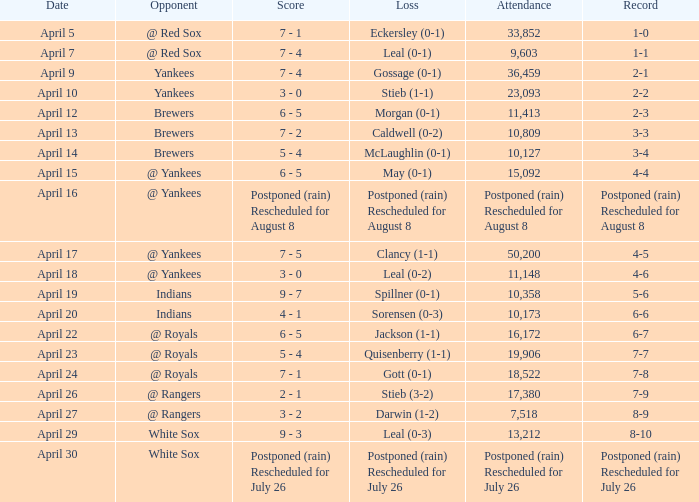What was the score of the game attended by 50,200? 7 - 5. 